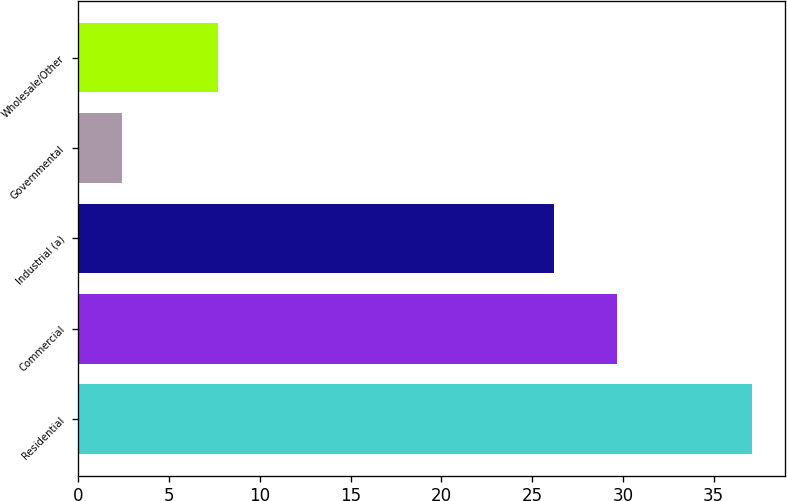Convert chart. <chart><loc_0><loc_0><loc_500><loc_500><bar_chart><fcel>Residential<fcel>Commercial<fcel>Industrial (a)<fcel>Governmental<fcel>Wholesale/Other<nl><fcel>37.1<fcel>29.67<fcel>26.2<fcel>2.4<fcel>7.7<nl></chart> 